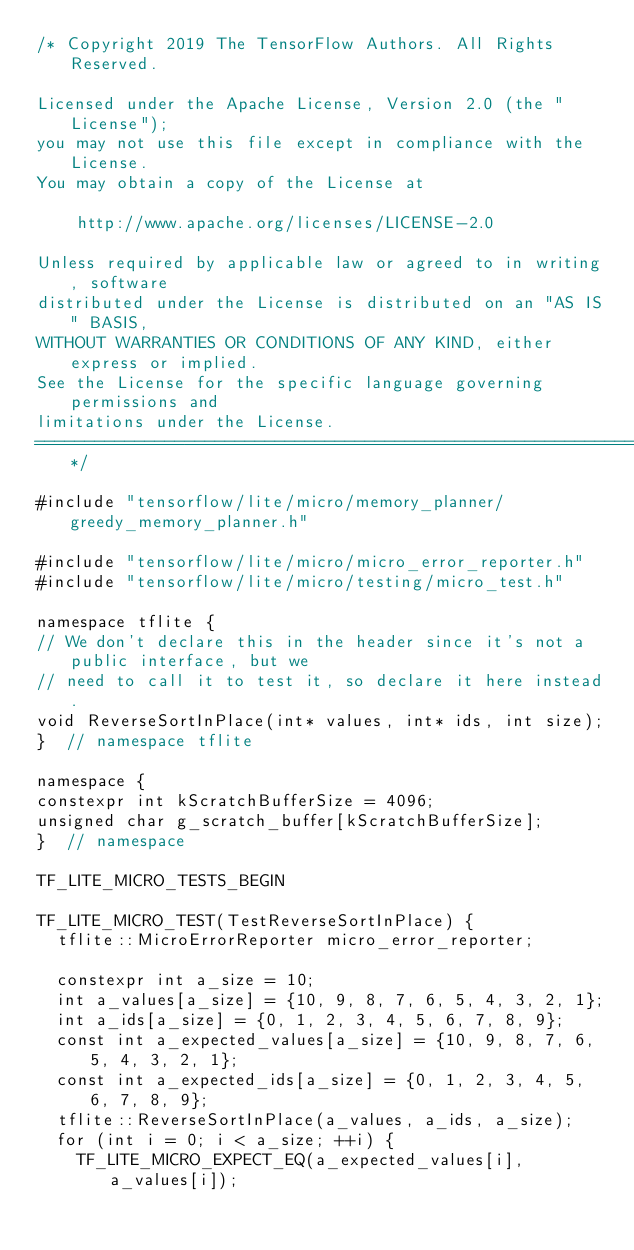<code> <loc_0><loc_0><loc_500><loc_500><_C++_>/* Copyright 2019 The TensorFlow Authors. All Rights Reserved.

Licensed under the Apache License, Version 2.0 (the "License");
you may not use this file except in compliance with the License.
You may obtain a copy of the License at

    http://www.apache.org/licenses/LICENSE-2.0

Unless required by applicable law or agreed to in writing, software
distributed under the License is distributed on an "AS IS" BASIS,
WITHOUT WARRANTIES OR CONDITIONS OF ANY KIND, either express or implied.
See the License for the specific language governing permissions and
limitations under the License.
==============================================================================*/

#include "tensorflow/lite/micro/memory_planner/greedy_memory_planner.h"

#include "tensorflow/lite/micro/micro_error_reporter.h"
#include "tensorflow/lite/micro/testing/micro_test.h"

namespace tflite {
// We don't declare this in the header since it's not a public interface, but we
// need to call it to test it, so declare it here instead.
void ReverseSortInPlace(int* values, int* ids, int size);
}  // namespace tflite

namespace {
constexpr int kScratchBufferSize = 4096;
unsigned char g_scratch_buffer[kScratchBufferSize];
}  // namespace

TF_LITE_MICRO_TESTS_BEGIN

TF_LITE_MICRO_TEST(TestReverseSortInPlace) {
  tflite::MicroErrorReporter micro_error_reporter;

  constexpr int a_size = 10;
  int a_values[a_size] = {10, 9, 8, 7, 6, 5, 4, 3, 2, 1};
  int a_ids[a_size] = {0, 1, 2, 3, 4, 5, 6, 7, 8, 9};
  const int a_expected_values[a_size] = {10, 9, 8, 7, 6, 5, 4, 3, 2, 1};
  const int a_expected_ids[a_size] = {0, 1, 2, 3, 4, 5, 6, 7, 8, 9};
  tflite::ReverseSortInPlace(a_values, a_ids, a_size);
  for (int i = 0; i < a_size; ++i) {
    TF_LITE_MICRO_EXPECT_EQ(a_expected_values[i], a_values[i]);</code> 